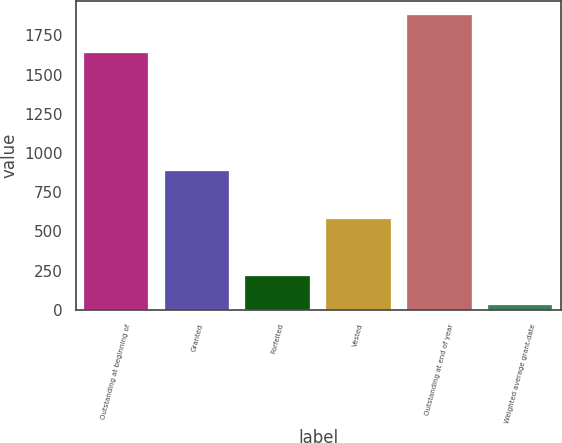Convert chart to OTSL. <chart><loc_0><loc_0><loc_500><loc_500><bar_chart><fcel>Outstanding at beginning of<fcel>Granted<fcel>Forfeited<fcel>Vested<fcel>Outstanding at end of year<fcel>Weighted average grant-date<nl><fcel>1639<fcel>883<fcel>217.9<fcel>580<fcel>1878<fcel>33.44<nl></chart> 